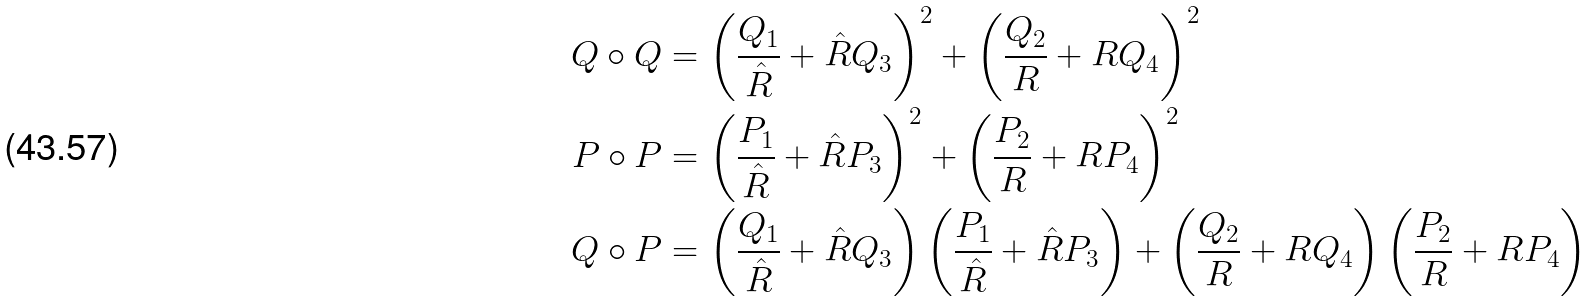<formula> <loc_0><loc_0><loc_500><loc_500>Q \circ Q & = \left ( \frac { Q _ { 1 } } { \hat { R } } + { \hat { R } } Q _ { 3 } \right ) ^ { 2 } + \left ( \frac { Q _ { 2 } } { R } + R Q _ { 4 } \right ) ^ { 2 } \\ P \circ P & = \left ( \frac { P _ { 1 } } { \hat { R } } + { \hat { R } } P _ { 3 } \right ) ^ { 2 } + \left ( \frac { P _ { 2 } } { R } + R P _ { 4 } \right ) ^ { 2 } \\ Q \circ P & = \left ( \frac { Q _ { 1 } } { \hat { R } } + { \hat { R } } Q _ { 3 } \right ) \left ( \frac { P _ { 1 } } { \hat { R } } + { \hat { R } } P _ { 3 } \right ) + \left ( \frac { Q _ { 2 } } { R } + R Q _ { 4 } \right ) \left ( \frac { P _ { 2 } } { R } + R P _ { 4 } \right ) \\</formula> 